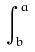Convert formula to latex. <formula><loc_0><loc_0><loc_500><loc_500>\int _ { b } ^ { a }</formula> 